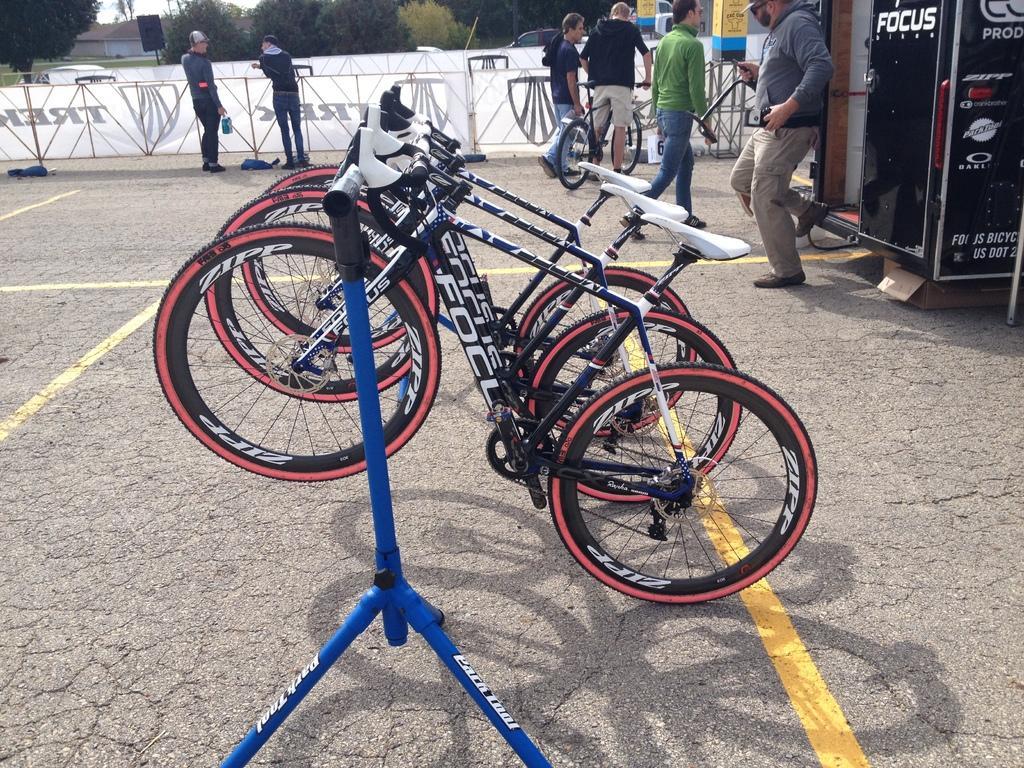In one or two sentences, can you explain what this image depicts? These are bicycles on a stand. Far this persons are standing. This person is holding a bicycle. This is a machine. Far there are number of trees and building. 